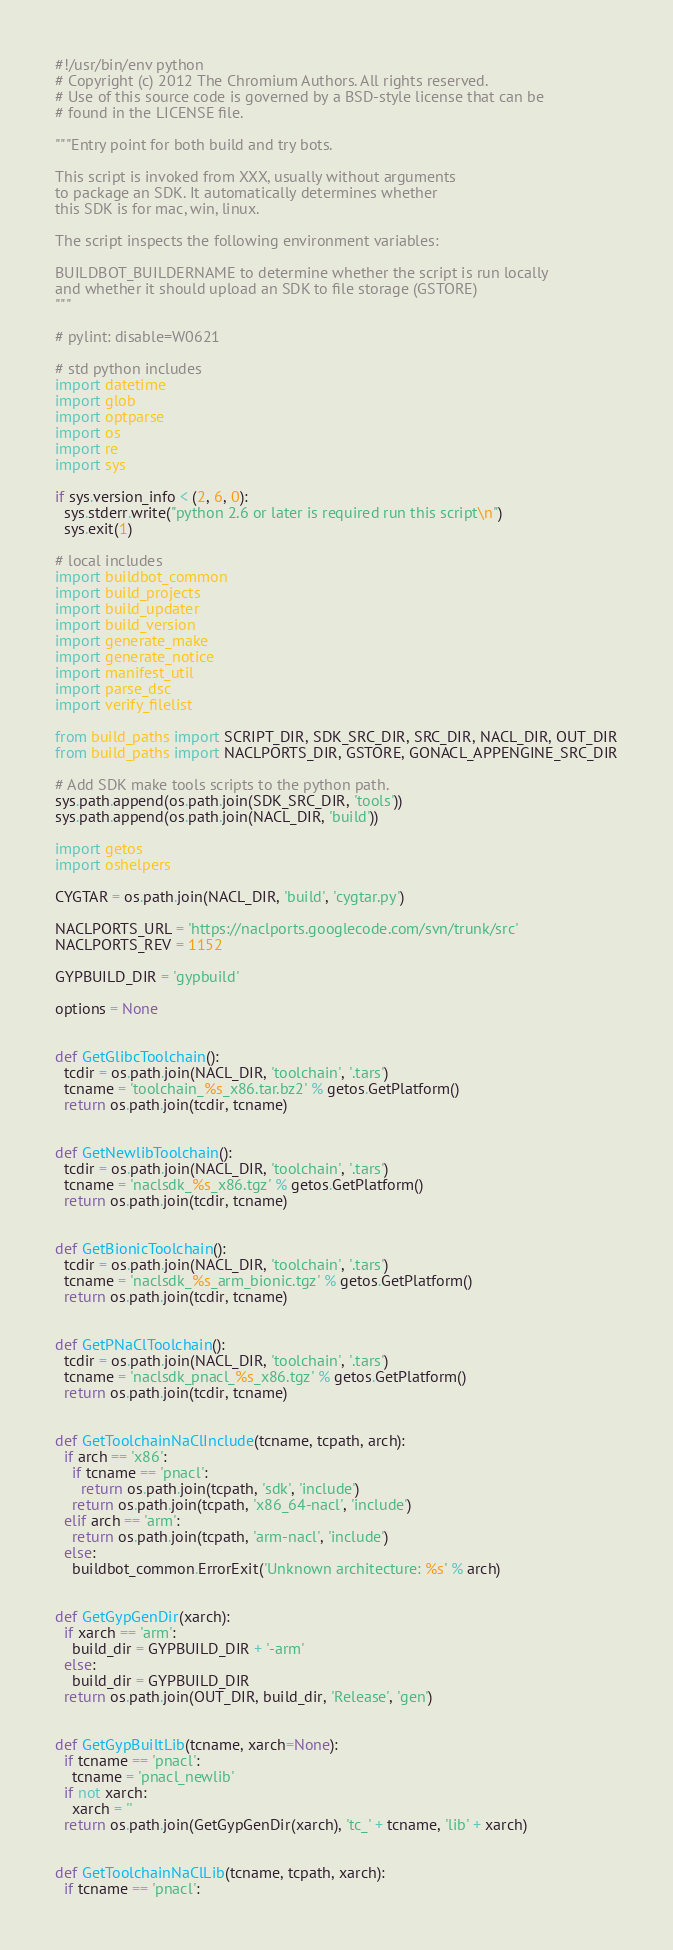<code> <loc_0><loc_0><loc_500><loc_500><_Python_>#!/usr/bin/env python
# Copyright (c) 2012 The Chromium Authors. All rights reserved.
# Use of this source code is governed by a BSD-style license that can be
# found in the LICENSE file.

"""Entry point for both build and try bots.

This script is invoked from XXX, usually without arguments
to package an SDK. It automatically determines whether
this SDK is for mac, win, linux.

The script inspects the following environment variables:

BUILDBOT_BUILDERNAME to determine whether the script is run locally
and whether it should upload an SDK to file storage (GSTORE)
"""

# pylint: disable=W0621

# std python includes
import datetime
import glob
import optparse
import os
import re
import sys

if sys.version_info < (2, 6, 0):
  sys.stderr.write("python 2.6 or later is required run this script\n")
  sys.exit(1)

# local includes
import buildbot_common
import build_projects
import build_updater
import build_version
import generate_make
import generate_notice
import manifest_util
import parse_dsc
import verify_filelist

from build_paths import SCRIPT_DIR, SDK_SRC_DIR, SRC_DIR, NACL_DIR, OUT_DIR
from build_paths import NACLPORTS_DIR, GSTORE, GONACL_APPENGINE_SRC_DIR

# Add SDK make tools scripts to the python path.
sys.path.append(os.path.join(SDK_SRC_DIR, 'tools'))
sys.path.append(os.path.join(NACL_DIR, 'build'))

import getos
import oshelpers

CYGTAR = os.path.join(NACL_DIR, 'build', 'cygtar.py')

NACLPORTS_URL = 'https://naclports.googlecode.com/svn/trunk/src'
NACLPORTS_REV = 1152

GYPBUILD_DIR = 'gypbuild'

options = None


def GetGlibcToolchain():
  tcdir = os.path.join(NACL_DIR, 'toolchain', '.tars')
  tcname = 'toolchain_%s_x86.tar.bz2' % getos.GetPlatform()
  return os.path.join(tcdir, tcname)


def GetNewlibToolchain():
  tcdir = os.path.join(NACL_DIR, 'toolchain', '.tars')
  tcname = 'naclsdk_%s_x86.tgz' % getos.GetPlatform()
  return os.path.join(tcdir, tcname)


def GetBionicToolchain():
  tcdir = os.path.join(NACL_DIR, 'toolchain', '.tars')
  tcname = 'naclsdk_%s_arm_bionic.tgz' % getos.GetPlatform()
  return os.path.join(tcdir, tcname)


def GetPNaClToolchain():
  tcdir = os.path.join(NACL_DIR, 'toolchain', '.tars')
  tcname = 'naclsdk_pnacl_%s_x86.tgz' % getos.GetPlatform()
  return os.path.join(tcdir, tcname)


def GetToolchainNaClInclude(tcname, tcpath, arch):
  if arch == 'x86':
    if tcname == 'pnacl':
      return os.path.join(tcpath, 'sdk', 'include')
    return os.path.join(tcpath, 'x86_64-nacl', 'include')
  elif arch == 'arm':
    return os.path.join(tcpath, 'arm-nacl', 'include')
  else:
    buildbot_common.ErrorExit('Unknown architecture: %s' % arch)


def GetGypGenDir(xarch):
  if xarch == 'arm':
    build_dir = GYPBUILD_DIR + '-arm'
  else:
    build_dir = GYPBUILD_DIR
  return os.path.join(OUT_DIR, build_dir, 'Release', 'gen')


def GetGypBuiltLib(tcname, xarch=None):
  if tcname == 'pnacl':
    tcname = 'pnacl_newlib'
  if not xarch:
    xarch = ''
  return os.path.join(GetGypGenDir(xarch), 'tc_' + tcname, 'lib' + xarch)


def GetToolchainNaClLib(tcname, tcpath, xarch):
  if tcname == 'pnacl':</code> 